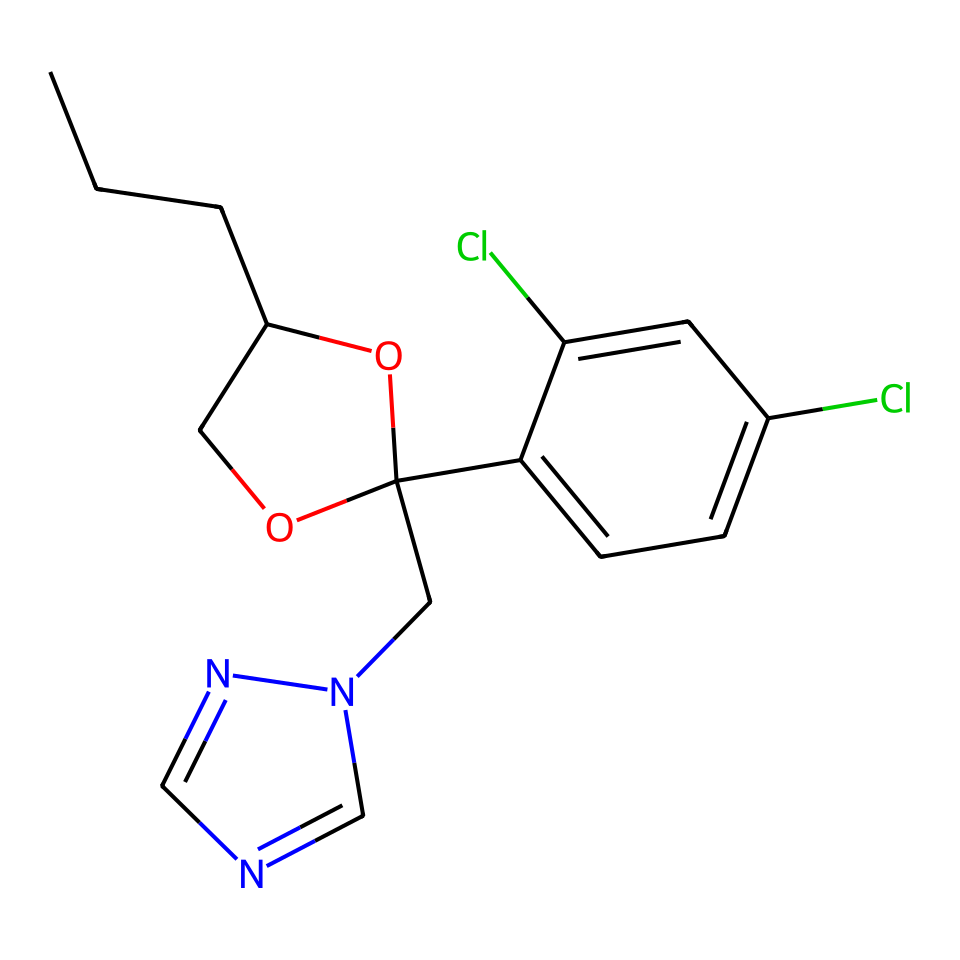What is the main functional group present in propiconazole? The chemical contains a hydroxyl group (–OH) indicated by the oxygen atom attached to a carbon chain, which is a characteristic of alcohols.
Answer: hydroxyl group How many chlorine atoms are in the structure of propiconazole? The structure has two chlorine atoms shown as "Cl" in the aromatic ring, which are substituents on the phenyl part of the molecule.
Answer: two What type of compound is propiconazole classified as? Based on its chemical structure and functional groups, it is a fungicide used in wood preservation and can also be classified as a triazole.
Answer: fungicide How many rings are present in the propiconazole structure? The structure contains two rings: one cyclic ether ring containing an oxygen atom and one aromatic benzene ring.
Answer: two What element in the structure contributes to its interaction with fungal disease? The triazole part of the structure contains nitrogen atoms, which help inhibit fungal enzymes, contributing to its effectiveness as a fungicide.
Answer: nitrogen What is the total number of carbon atoms in propiconazole? By counting all the carbon atoms in the structure, including those in the rings and those in the carbon chains, there are 14 carbon atoms in total.
Answer: fourteen 